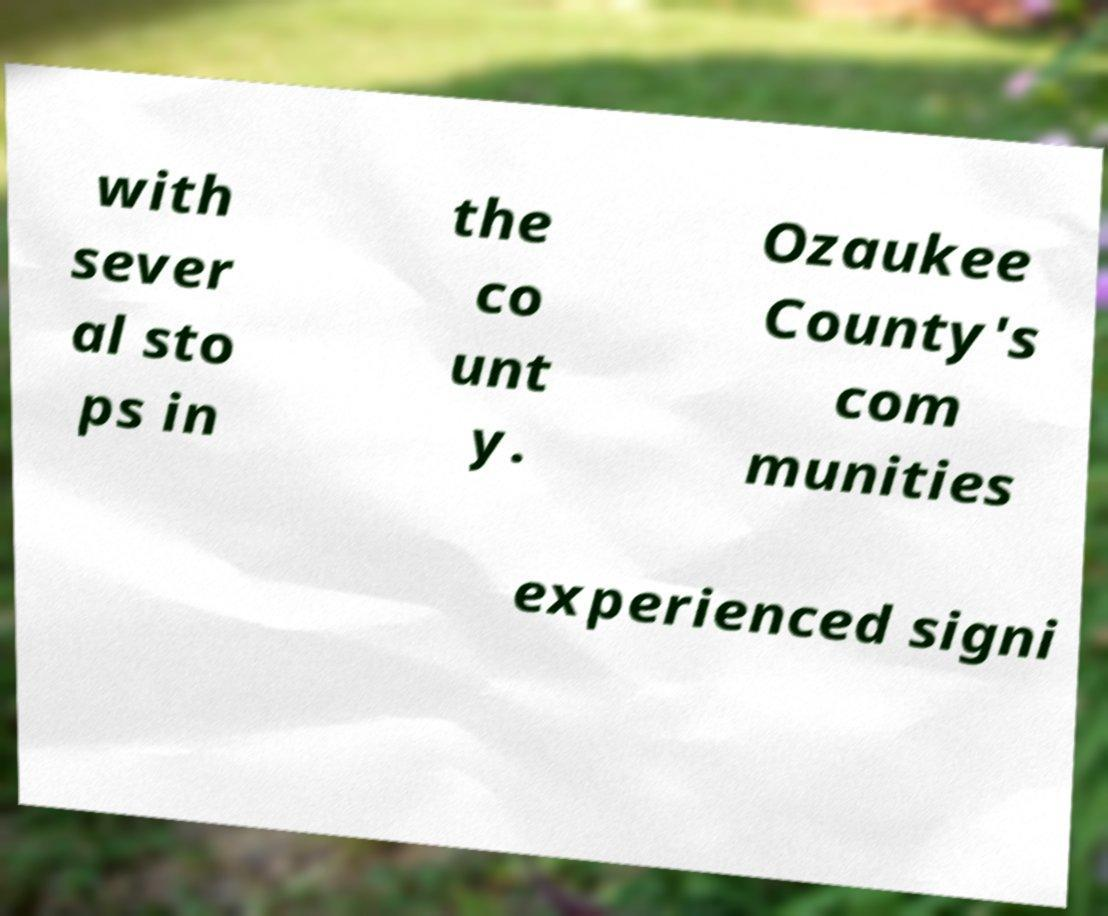I need the written content from this picture converted into text. Can you do that? with sever al sto ps in the co unt y. Ozaukee County's com munities experienced signi 